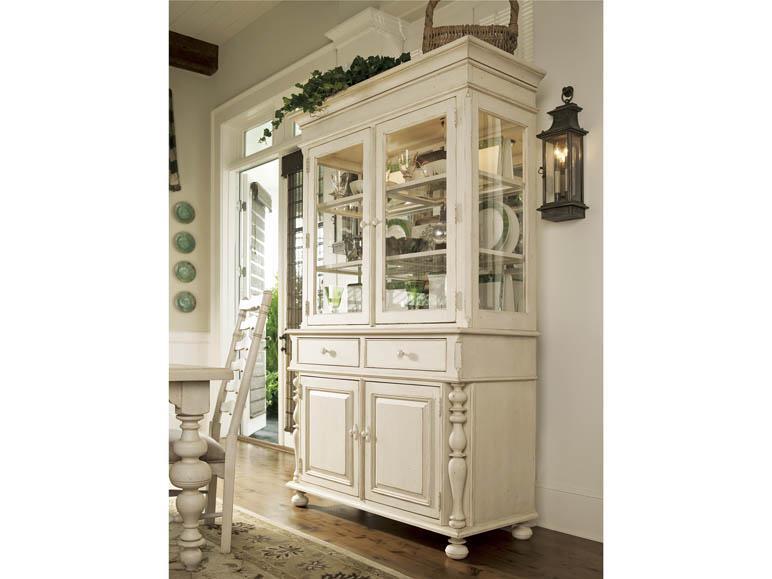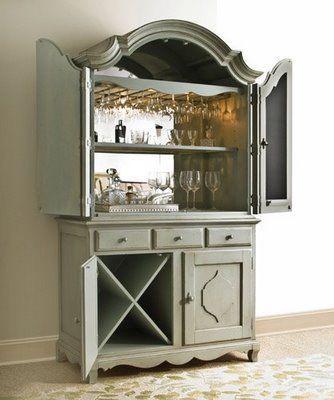The first image is the image on the left, the second image is the image on the right. Analyze the images presented: Is the assertion "A wooden painted hutch has a bottom door open that shows an X shaped space for storing bottles of wine, and glasses hanging upside down in the upper section." valid? Answer yes or no. Yes. The first image is the image on the left, the second image is the image on the right. Analyze the images presented: Is the assertion "A brown cabinet is used for storage in the image on the right." valid? Answer yes or no. No. 